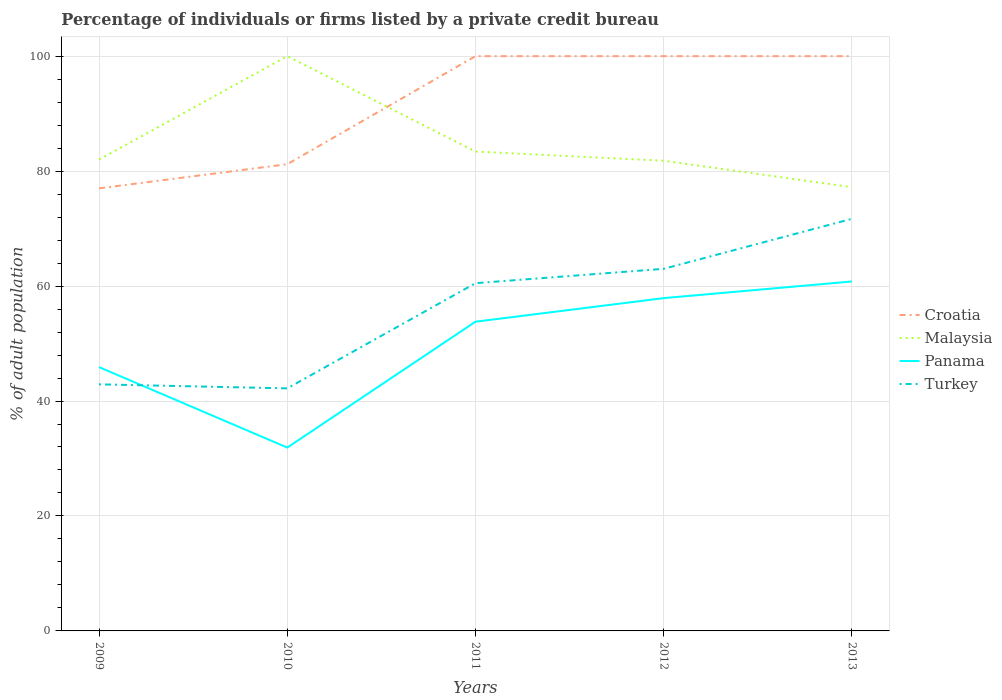Does the line corresponding to Malaysia intersect with the line corresponding to Panama?
Provide a short and direct response. No. Across all years, what is the maximum percentage of population listed by a private credit bureau in Turkey?
Your response must be concise. 42.2. In which year was the percentage of population listed by a private credit bureau in Malaysia maximum?
Make the answer very short. 2013. What is the total percentage of population listed by a private credit bureau in Panama in the graph?
Offer a very short reply. -2.9. What is the difference between the highest and the second highest percentage of population listed by a private credit bureau in Malaysia?
Your answer should be compact. 22.8. What is the difference between the highest and the lowest percentage of population listed by a private credit bureau in Turkey?
Ensure brevity in your answer.  3. How many years are there in the graph?
Provide a short and direct response. 5. What is the difference between two consecutive major ticks on the Y-axis?
Make the answer very short. 20. Does the graph contain any zero values?
Keep it short and to the point. No. Does the graph contain grids?
Your answer should be very brief. Yes. Where does the legend appear in the graph?
Ensure brevity in your answer.  Center right. How many legend labels are there?
Your answer should be compact. 4. What is the title of the graph?
Keep it short and to the point. Percentage of individuals or firms listed by a private credit bureau. What is the label or title of the Y-axis?
Your answer should be compact. % of adult population. What is the % of adult population in Malaysia in 2009?
Provide a succinct answer. 82. What is the % of adult population of Panama in 2009?
Offer a terse response. 45.9. What is the % of adult population in Turkey in 2009?
Keep it short and to the point. 42.9. What is the % of adult population of Croatia in 2010?
Make the answer very short. 81.2. What is the % of adult population of Panama in 2010?
Your answer should be compact. 31.9. What is the % of adult population of Turkey in 2010?
Give a very brief answer. 42.2. What is the % of adult population of Malaysia in 2011?
Your answer should be compact. 83.4. What is the % of adult population of Panama in 2011?
Offer a terse response. 53.8. What is the % of adult population in Turkey in 2011?
Your answer should be compact. 60.5. What is the % of adult population of Malaysia in 2012?
Provide a succinct answer. 81.8. What is the % of adult population in Panama in 2012?
Offer a very short reply. 57.9. What is the % of adult population in Croatia in 2013?
Offer a terse response. 100. What is the % of adult population in Malaysia in 2013?
Make the answer very short. 77.2. What is the % of adult population of Panama in 2013?
Provide a succinct answer. 60.8. What is the % of adult population of Turkey in 2013?
Make the answer very short. 71.7. Across all years, what is the maximum % of adult population in Malaysia?
Make the answer very short. 100. Across all years, what is the maximum % of adult population in Panama?
Provide a short and direct response. 60.8. Across all years, what is the maximum % of adult population of Turkey?
Your answer should be compact. 71.7. Across all years, what is the minimum % of adult population of Croatia?
Offer a very short reply. 77. Across all years, what is the minimum % of adult population in Malaysia?
Make the answer very short. 77.2. Across all years, what is the minimum % of adult population of Panama?
Ensure brevity in your answer.  31.9. Across all years, what is the minimum % of adult population in Turkey?
Give a very brief answer. 42.2. What is the total % of adult population in Croatia in the graph?
Offer a terse response. 458.2. What is the total % of adult population in Malaysia in the graph?
Give a very brief answer. 424.4. What is the total % of adult population in Panama in the graph?
Keep it short and to the point. 250.3. What is the total % of adult population in Turkey in the graph?
Your response must be concise. 280.3. What is the difference between the % of adult population of Croatia in 2009 and that in 2010?
Provide a succinct answer. -4.2. What is the difference between the % of adult population of Malaysia in 2009 and that in 2010?
Ensure brevity in your answer.  -18. What is the difference between the % of adult population of Panama in 2009 and that in 2010?
Make the answer very short. 14. What is the difference between the % of adult population in Turkey in 2009 and that in 2010?
Offer a very short reply. 0.7. What is the difference between the % of adult population in Panama in 2009 and that in 2011?
Provide a succinct answer. -7.9. What is the difference between the % of adult population in Turkey in 2009 and that in 2011?
Keep it short and to the point. -17.6. What is the difference between the % of adult population in Turkey in 2009 and that in 2012?
Ensure brevity in your answer.  -20.1. What is the difference between the % of adult population in Croatia in 2009 and that in 2013?
Give a very brief answer. -23. What is the difference between the % of adult population in Panama in 2009 and that in 2013?
Your answer should be compact. -14.9. What is the difference between the % of adult population in Turkey in 2009 and that in 2013?
Ensure brevity in your answer.  -28.8. What is the difference between the % of adult population of Croatia in 2010 and that in 2011?
Offer a very short reply. -18.8. What is the difference between the % of adult population of Panama in 2010 and that in 2011?
Your answer should be very brief. -21.9. What is the difference between the % of adult population of Turkey in 2010 and that in 2011?
Provide a short and direct response. -18.3. What is the difference between the % of adult population in Croatia in 2010 and that in 2012?
Give a very brief answer. -18.8. What is the difference between the % of adult population of Turkey in 2010 and that in 2012?
Give a very brief answer. -20.8. What is the difference between the % of adult population of Croatia in 2010 and that in 2013?
Make the answer very short. -18.8. What is the difference between the % of adult population in Malaysia in 2010 and that in 2013?
Your answer should be very brief. 22.8. What is the difference between the % of adult population in Panama in 2010 and that in 2013?
Provide a short and direct response. -28.9. What is the difference between the % of adult population of Turkey in 2010 and that in 2013?
Your answer should be very brief. -29.5. What is the difference between the % of adult population of Croatia in 2011 and that in 2012?
Your response must be concise. 0. What is the difference between the % of adult population of Malaysia in 2011 and that in 2012?
Give a very brief answer. 1.6. What is the difference between the % of adult population of Panama in 2011 and that in 2012?
Make the answer very short. -4.1. What is the difference between the % of adult population in Turkey in 2011 and that in 2012?
Provide a short and direct response. -2.5. What is the difference between the % of adult population of Croatia in 2011 and that in 2013?
Your answer should be very brief. 0. What is the difference between the % of adult population of Croatia in 2012 and that in 2013?
Ensure brevity in your answer.  0. What is the difference between the % of adult population of Panama in 2012 and that in 2013?
Provide a short and direct response. -2.9. What is the difference between the % of adult population of Croatia in 2009 and the % of adult population of Malaysia in 2010?
Give a very brief answer. -23. What is the difference between the % of adult population in Croatia in 2009 and the % of adult population in Panama in 2010?
Your answer should be very brief. 45.1. What is the difference between the % of adult population of Croatia in 2009 and the % of adult population of Turkey in 2010?
Your answer should be very brief. 34.8. What is the difference between the % of adult population in Malaysia in 2009 and the % of adult population in Panama in 2010?
Give a very brief answer. 50.1. What is the difference between the % of adult population of Malaysia in 2009 and the % of adult population of Turkey in 2010?
Provide a succinct answer. 39.8. What is the difference between the % of adult population in Panama in 2009 and the % of adult population in Turkey in 2010?
Give a very brief answer. 3.7. What is the difference between the % of adult population of Croatia in 2009 and the % of adult population of Panama in 2011?
Offer a very short reply. 23.2. What is the difference between the % of adult population of Croatia in 2009 and the % of adult population of Turkey in 2011?
Offer a very short reply. 16.5. What is the difference between the % of adult population in Malaysia in 2009 and the % of adult population in Panama in 2011?
Provide a succinct answer. 28.2. What is the difference between the % of adult population in Malaysia in 2009 and the % of adult population in Turkey in 2011?
Provide a succinct answer. 21.5. What is the difference between the % of adult population in Panama in 2009 and the % of adult population in Turkey in 2011?
Offer a very short reply. -14.6. What is the difference between the % of adult population of Croatia in 2009 and the % of adult population of Malaysia in 2012?
Offer a terse response. -4.8. What is the difference between the % of adult population of Croatia in 2009 and the % of adult population of Panama in 2012?
Provide a short and direct response. 19.1. What is the difference between the % of adult population in Malaysia in 2009 and the % of adult population in Panama in 2012?
Provide a short and direct response. 24.1. What is the difference between the % of adult population in Malaysia in 2009 and the % of adult population in Turkey in 2012?
Offer a terse response. 19. What is the difference between the % of adult population in Panama in 2009 and the % of adult population in Turkey in 2012?
Your answer should be very brief. -17.1. What is the difference between the % of adult population in Croatia in 2009 and the % of adult population in Panama in 2013?
Your answer should be very brief. 16.2. What is the difference between the % of adult population of Malaysia in 2009 and the % of adult population of Panama in 2013?
Keep it short and to the point. 21.2. What is the difference between the % of adult population in Malaysia in 2009 and the % of adult population in Turkey in 2013?
Your response must be concise. 10.3. What is the difference between the % of adult population in Panama in 2009 and the % of adult population in Turkey in 2013?
Offer a terse response. -25.8. What is the difference between the % of adult population of Croatia in 2010 and the % of adult population of Malaysia in 2011?
Offer a very short reply. -2.2. What is the difference between the % of adult population in Croatia in 2010 and the % of adult population in Panama in 2011?
Your response must be concise. 27.4. What is the difference between the % of adult population of Croatia in 2010 and the % of adult population of Turkey in 2011?
Provide a short and direct response. 20.7. What is the difference between the % of adult population of Malaysia in 2010 and the % of adult population of Panama in 2011?
Offer a very short reply. 46.2. What is the difference between the % of adult population in Malaysia in 2010 and the % of adult population in Turkey in 2011?
Offer a terse response. 39.5. What is the difference between the % of adult population of Panama in 2010 and the % of adult population of Turkey in 2011?
Provide a short and direct response. -28.6. What is the difference between the % of adult population of Croatia in 2010 and the % of adult population of Panama in 2012?
Provide a short and direct response. 23.3. What is the difference between the % of adult population in Malaysia in 2010 and the % of adult population in Panama in 2012?
Provide a short and direct response. 42.1. What is the difference between the % of adult population in Panama in 2010 and the % of adult population in Turkey in 2012?
Give a very brief answer. -31.1. What is the difference between the % of adult population of Croatia in 2010 and the % of adult population of Malaysia in 2013?
Your answer should be very brief. 4. What is the difference between the % of adult population in Croatia in 2010 and the % of adult population in Panama in 2013?
Give a very brief answer. 20.4. What is the difference between the % of adult population of Croatia in 2010 and the % of adult population of Turkey in 2013?
Offer a terse response. 9.5. What is the difference between the % of adult population in Malaysia in 2010 and the % of adult population in Panama in 2013?
Your answer should be compact. 39.2. What is the difference between the % of adult population in Malaysia in 2010 and the % of adult population in Turkey in 2013?
Ensure brevity in your answer.  28.3. What is the difference between the % of adult population of Panama in 2010 and the % of adult population of Turkey in 2013?
Make the answer very short. -39.8. What is the difference between the % of adult population in Croatia in 2011 and the % of adult population in Malaysia in 2012?
Your answer should be very brief. 18.2. What is the difference between the % of adult population of Croatia in 2011 and the % of adult population of Panama in 2012?
Offer a terse response. 42.1. What is the difference between the % of adult population in Croatia in 2011 and the % of adult population in Turkey in 2012?
Your response must be concise. 37. What is the difference between the % of adult population of Malaysia in 2011 and the % of adult population of Panama in 2012?
Your answer should be compact. 25.5. What is the difference between the % of adult population of Malaysia in 2011 and the % of adult population of Turkey in 2012?
Offer a terse response. 20.4. What is the difference between the % of adult population of Panama in 2011 and the % of adult population of Turkey in 2012?
Provide a short and direct response. -9.2. What is the difference between the % of adult population in Croatia in 2011 and the % of adult population in Malaysia in 2013?
Ensure brevity in your answer.  22.8. What is the difference between the % of adult population of Croatia in 2011 and the % of adult population of Panama in 2013?
Provide a short and direct response. 39.2. What is the difference between the % of adult population in Croatia in 2011 and the % of adult population in Turkey in 2013?
Provide a short and direct response. 28.3. What is the difference between the % of adult population of Malaysia in 2011 and the % of adult population of Panama in 2013?
Your response must be concise. 22.6. What is the difference between the % of adult population in Panama in 2011 and the % of adult population in Turkey in 2013?
Your answer should be compact. -17.9. What is the difference between the % of adult population of Croatia in 2012 and the % of adult population of Malaysia in 2013?
Give a very brief answer. 22.8. What is the difference between the % of adult population of Croatia in 2012 and the % of adult population of Panama in 2013?
Give a very brief answer. 39.2. What is the difference between the % of adult population in Croatia in 2012 and the % of adult population in Turkey in 2013?
Provide a succinct answer. 28.3. What is the difference between the % of adult population of Panama in 2012 and the % of adult population of Turkey in 2013?
Your answer should be very brief. -13.8. What is the average % of adult population of Croatia per year?
Provide a succinct answer. 91.64. What is the average % of adult population in Malaysia per year?
Provide a short and direct response. 84.88. What is the average % of adult population in Panama per year?
Your answer should be compact. 50.06. What is the average % of adult population in Turkey per year?
Offer a very short reply. 56.06. In the year 2009, what is the difference between the % of adult population of Croatia and % of adult population of Panama?
Your answer should be very brief. 31.1. In the year 2009, what is the difference between the % of adult population of Croatia and % of adult population of Turkey?
Your response must be concise. 34.1. In the year 2009, what is the difference between the % of adult population in Malaysia and % of adult population in Panama?
Your response must be concise. 36.1. In the year 2009, what is the difference between the % of adult population in Malaysia and % of adult population in Turkey?
Offer a terse response. 39.1. In the year 2009, what is the difference between the % of adult population in Panama and % of adult population in Turkey?
Offer a very short reply. 3. In the year 2010, what is the difference between the % of adult population of Croatia and % of adult population of Malaysia?
Give a very brief answer. -18.8. In the year 2010, what is the difference between the % of adult population of Croatia and % of adult population of Panama?
Provide a short and direct response. 49.3. In the year 2010, what is the difference between the % of adult population of Malaysia and % of adult population of Panama?
Provide a succinct answer. 68.1. In the year 2010, what is the difference between the % of adult population in Malaysia and % of adult population in Turkey?
Keep it short and to the point. 57.8. In the year 2011, what is the difference between the % of adult population in Croatia and % of adult population in Panama?
Offer a terse response. 46.2. In the year 2011, what is the difference between the % of adult population of Croatia and % of adult population of Turkey?
Offer a terse response. 39.5. In the year 2011, what is the difference between the % of adult population in Malaysia and % of adult population in Panama?
Offer a terse response. 29.6. In the year 2011, what is the difference between the % of adult population in Malaysia and % of adult population in Turkey?
Offer a terse response. 22.9. In the year 2011, what is the difference between the % of adult population of Panama and % of adult population of Turkey?
Offer a terse response. -6.7. In the year 2012, what is the difference between the % of adult population in Croatia and % of adult population in Panama?
Your answer should be compact. 42.1. In the year 2012, what is the difference between the % of adult population in Malaysia and % of adult population in Panama?
Give a very brief answer. 23.9. In the year 2013, what is the difference between the % of adult population in Croatia and % of adult population in Malaysia?
Your response must be concise. 22.8. In the year 2013, what is the difference between the % of adult population in Croatia and % of adult population in Panama?
Offer a terse response. 39.2. In the year 2013, what is the difference between the % of adult population in Croatia and % of adult population in Turkey?
Your answer should be compact. 28.3. In the year 2013, what is the difference between the % of adult population of Malaysia and % of adult population of Panama?
Provide a succinct answer. 16.4. In the year 2013, what is the difference between the % of adult population of Malaysia and % of adult population of Turkey?
Your response must be concise. 5.5. In the year 2013, what is the difference between the % of adult population of Panama and % of adult population of Turkey?
Make the answer very short. -10.9. What is the ratio of the % of adult population in Croatia in 2009 to that in 2010?
Provide a short and direct response. 0.95. What is the ratio of the % of adult population of Malaysia in 2009 to that in 2010?
Offer a terse response. 0.82. What is the ratio of the % of adult population in Panama in 2009 to that in 2010?
Offer a terse response. 1.44. What is the ratio of the % of adult population in Turkey in 2009 to that in 2010?
Keep it short and to the point. 1.02. What is the ratio of the % of adult population of Croatia in 2009 to that in 2011?
Your answer should be very brief. 0.77. What is the ratio of the % of adult population of Malaysia in 2009 to that in 2011?
Make the answer very short. 0.98. What is the ratio of the % of adult population in Panama in 2009 to that in 2011?
Your response must be concise. 0.85. What is the ratio of the % of adult population in Turkey in 2009 to that in 2011?
Give a very brief answer. 0.71. What is the ratio of the % of adult population of Croatia in 2009 to that in 2012?
Your answer should be compact. 0.77. What is the ratio of the % of adult population of Panama in 2009 to that in 2012?
Keep it short and to the point. 0.79. What is the ratio of the % of adult population of Turkey in 2009 to that in 2012?
Your answer should be very brief. 0.68. What is the ratio of the % of adult population of Croatia in 2009 to that in 2013?
Offer a terse response. 0.77. What is the ratio of the % of adult population in Malaysia in 2009 to that in 2013?
Your response must be concise. 1.06. What is the ratio of the % of adult population in Panama in 2009 to that in 2013?
Offer a very short reply. 0.75. What is the ratio of the % of adult population in Turkey in 2009 to that in 2013?
Ensure brevity in your answer.  0.6. What is the ratio of the % of adult population of Croatia in 2010 to that in 2011?
Offer a very short reply. 0.81. What is the ratio of the % of adult population of Malaysia in 2010 to that in 2011?
Your answer should be very brief. 1.2. What is the ratio of the % of adult population in Panama in 2010 to that in 2011?
Your response must be concise. 0.59. What is the ratio of the % of adult population in Turkey in 2010 to that in 2011?
Your answer should be compact. 0.7. What is the ratio of the % of adult population of Croatia in 2010 to that in 2012?
Ensure brevity in your answer.  0.81. What is the ratio of the % of adult population in Malaysia in 2010 to that in 2012?
Keep it short and to the point. 1.22. What is the ratio of the % of adult population of Panama in 2010 to that in 2012?
Provide a short and direct response. 0.55. What is the ratio of the % of adult population of Turkey in 2010 to that in 2012?
Make the answer very short. 0.67. What is the ratio of the % of adult population of Croatia in 2010 to that in 2013?
Provide a short and direct response. 0.81. What is the ratio of the % of adult population in Malaysia in 2010 to that in 2013?
Ensure brevity in your answer.  1.3. What is the ratio of the % of adult population of Panama in 2010 to that in 2013?
Make the answer very short. 0.52. What is the ratio of the % of adult population of Turkey in 2010 to that in 2013?
Keep it short and to the point. 0.59. What is the ratio of the % of adult population in Malaysia in 2011 to that in 2012?
Your answer should be compact. 1.02. What is the ratio of the % of adult population of Panama in 2011 to that in 2012?
Your response must be concise. 0.93. What is the ratio of the % of adult population of Turkey in 2011 to that in 2012?
Keep it short and to the point. 0.96. What is the ratio of the % of adult population of Croatia in 2011 to that in 2013?
Provide a short and direct response. 1. What is the ratio of the % of adult population of Malaysia in 2011 to that in 2013?
Your answer should be compact. 1.08. What is the ratio of the % of adult population in Panama in 2011 to that in 2013?
Offer a very short reply. 0.88. What is the ratio of the % of adult population in Turkey in 2011 to that in 2013?
Provide a succinct answer. 0.84. What is the ratio of the % of adult population of Malaysia in 2012 to that in 2013?
Offer a very short reply. 1.06. What is the ratio of the % of adult population of Panama in 2012 to that in 2013?
Keep it short and to the point. 0.95. What is the ratio of the % of adult population in Turkey in 2012 to that in 2013?
Ensure brevity in your answer.  0.88. What is the difference between the highest and the second highest % of adult population of Croatia?
Keep it short and to the point. 0. What is the difference between the highest and the second highest % of adult population in Malaysia?
Your answer should be very brief. 16.6. What is the difference between the highest and the lowest % of adult population of Malaysia?
Provide a succinct answer. 22.8. What is the difference between the highest and the lowest % of adult population of Panama?
Your answer should be very brief. 28.9. What is the difference between the highest and the lowest % of adult population in Turkey?
Make the answer very short. 29.5. 